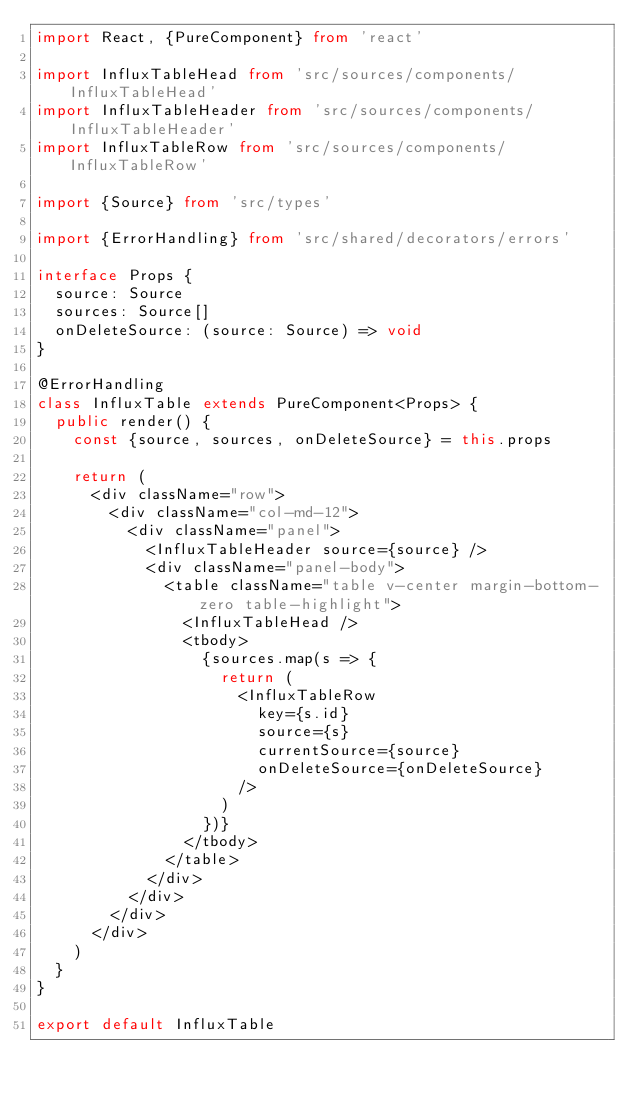<code> <loc_0><loc_0><loc_500><loc_500><_TypeScript_>import React, {PureComponent} from 'react'

import InfluxTableHead from 'src/sources/components/InfluxTableHead'
import InfluxTableHeader from 'src/sources/components/InfluxTableHeader'
import InfluxTableRow from 'src/sources/components/InfluxTableRow'

import {Source} from 'src/types'

import {ErrorHandling} from 'src/shared/decorators/errors'

interface Props {
  source: Source
  sources: Source[]
  onDeleteSource: (source: Source) => void
}

@ErrorHandling
class InfluxTable extends PureComponent<Props> {
  public render() {
    const {source, sources, onDeleteSource} = this.props

    return (
      <div className="row">
        <div className="col-md-12">
          <div className="panel">
            <InfluxTableHeader source={source} />
            <div className="panel-body">
              <table className="table v-center margin-bottom-zero table-highlight">
                <InfluxTableHead />
                <tbody>
                  {sources.map(s => {
                    return (
                      <InfluxTableRow
                        key={s.id}
                        source={s}
                        currentSource={source}
                        onDeleteSource={onDeleteSource}
                      />
                    )
                  })}
                </tbody>
              </table>
            </div>
          </div>
        </div>
      </div>
    )
  }
}

export default InfluxTable
</code> 